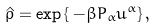<formula> <loc_0><loc_0><loc_500><loc_500>\hat { \varrho } = \exp \left \{ \, - \beta P _ { \alpha } u ^ { \alpha } \right \} ,</formula> 